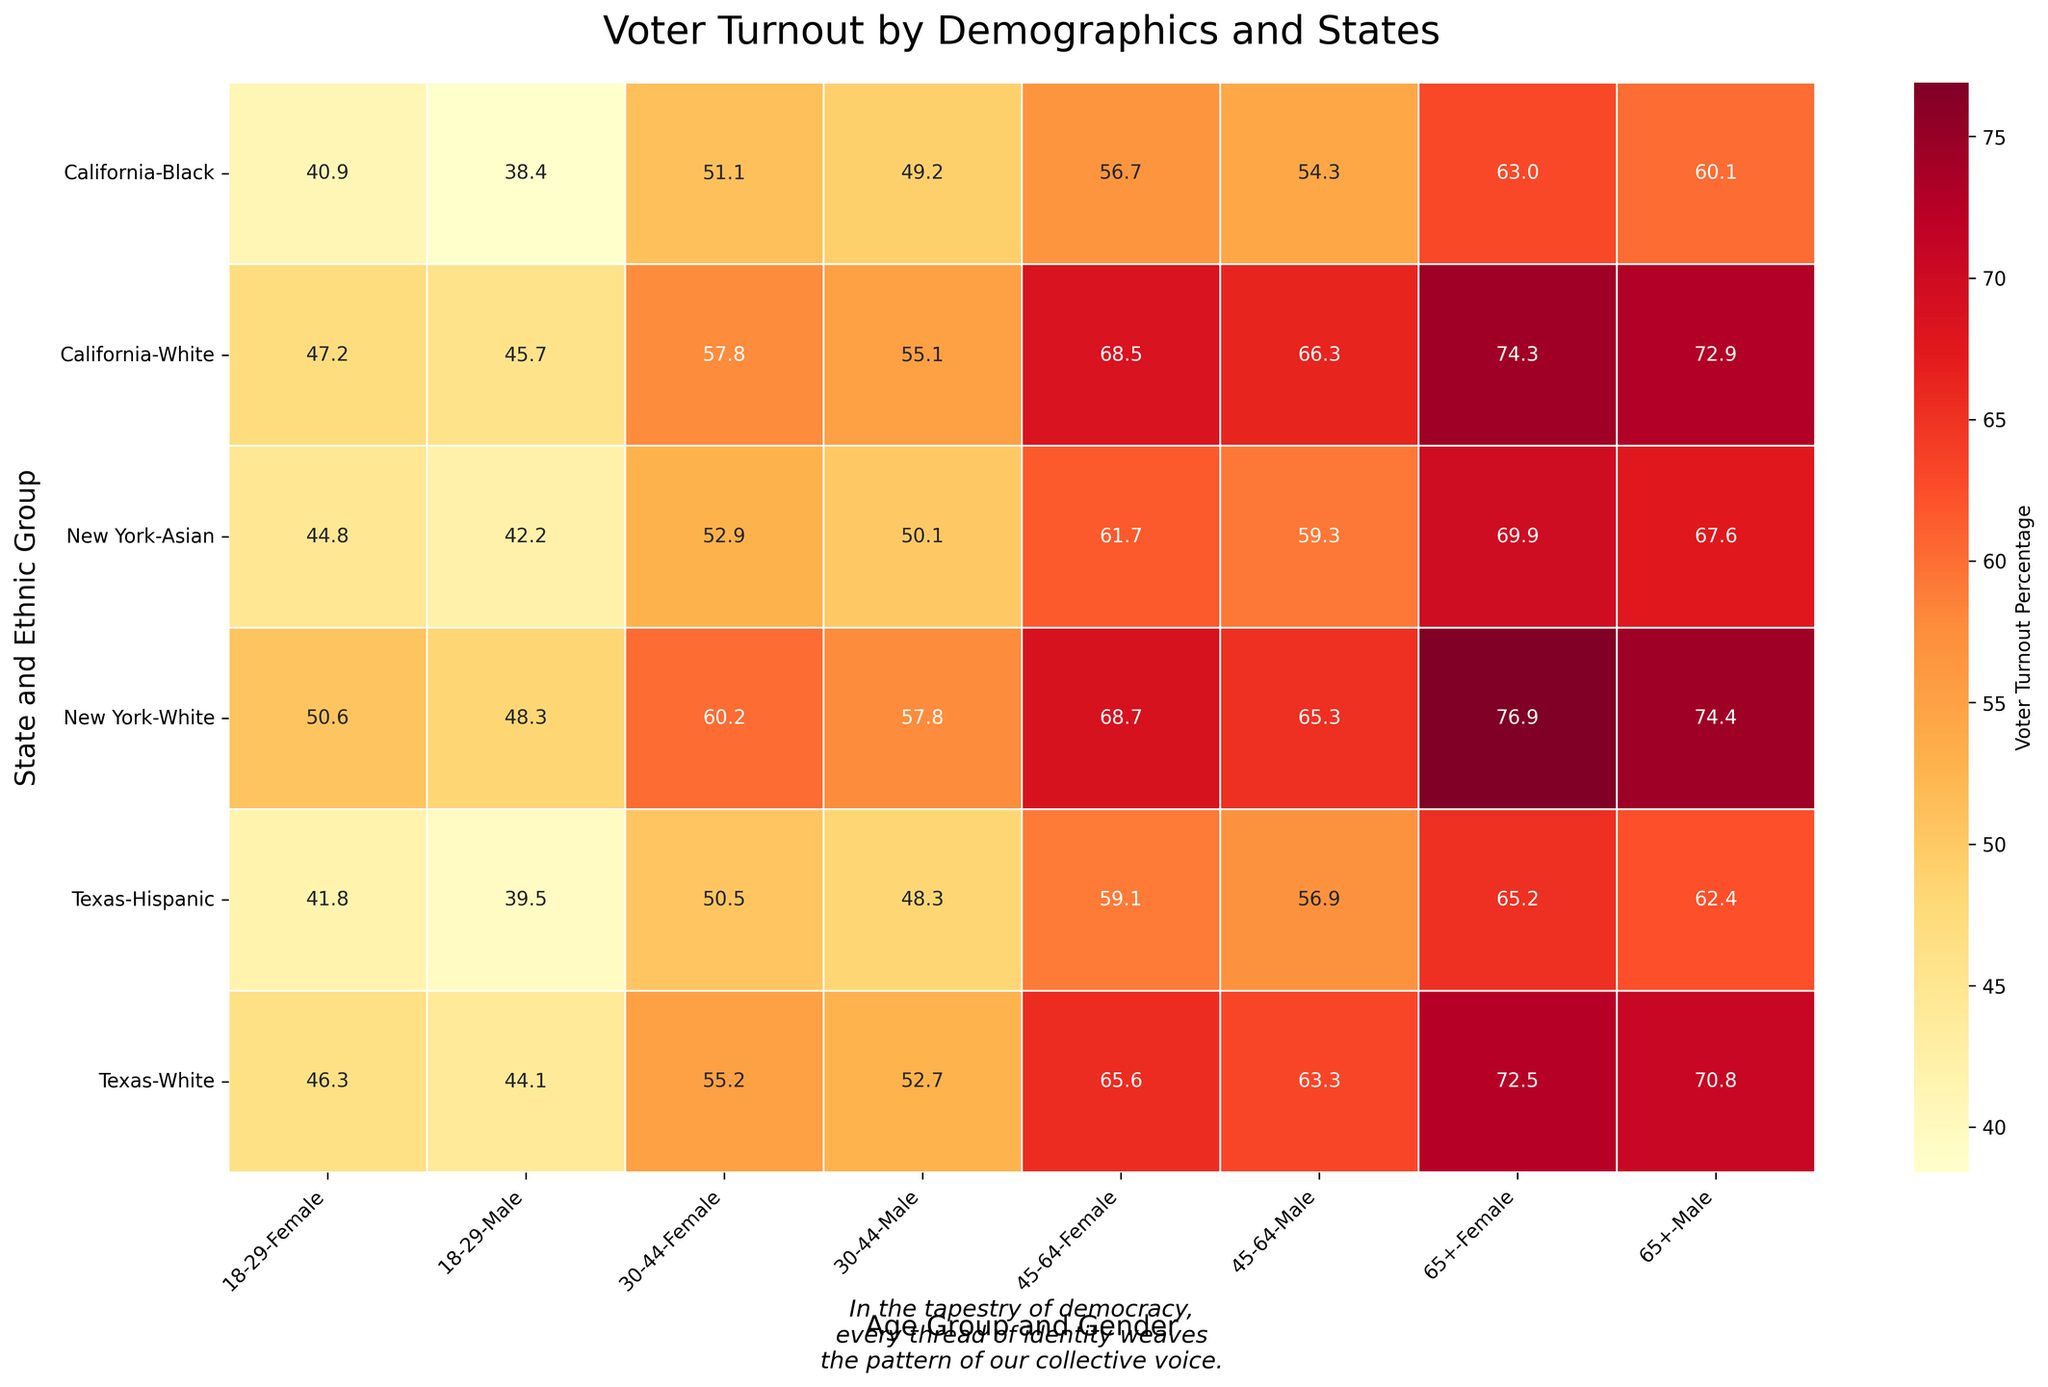What is the title of the heatmap? The title is found at the top-center of the plot.
Answer: Voter Turnout by Demographics and States Which age group and gender in Texas had the highest voter turnout percentage in 2016? Locate the Texas section, then look for the highest number under the 2016 Election Year. The highest value is under the 65+ age group and Female gender.
Answer: 72.5 Compare the voter turnout percentage of White males aged 18-29 in California for 2020 with that of Texas in 2016. Which state had the higher turnout and by how much? Find the White males aged 18-29 in the heatmap for both California in 2020 and Texas in 2016. The voter turnout percentages are 45.7 for California and 44.1 for Texas. The difference is 45.7 - 44.1.
Answer: California by 1.6 What is the average voter turnout percentage for Black females in California across all listed age groups in 2020? Identify the values for Black females in California for 2020, then sum them up and divide by the number of age groups. The turnout percentages are 40.9, 51.1, 56.7, and 63.0. The average is (40.9 + 51.1 + 56.7 + 63.0) / 4.
Answer: 52.9 Which ethnic group in New York showed the highest voter turnout among the 65+ age group in 2020? Locate New York's section and find the 65+ age group. Compare the percentages for each ethnic group, where White and Asian are options.
Answer: White females What is the voter turnout percentage difference between Hispanic males and females aged 45-64 in Texas for the 2020 election? Identify the column for Hispanics aged 45-64, compare values for males and females. Males have 56.9 and females have 59.1. The difference is 59.1 - 56.9.
Answer: 2.2 Is there any instance where the voter turnout percentage for Black males aged 18-29 is higher than that for White males aged 30-44 in the same state and election year? Compare the voter turnout for Black males aged 18-29 and White males aged 30-44 within the same state and election year in the heatmap. Across provided data, Black males aged 18-29 do not exceed White males aged 30-44.
Answer: No What are the voter turnout percentages for Asian females aged 30-44 and 45-64 in New York for 2020? Locate the values for Asian females in New York, specifically in the age groups 30-44 and 45-64 for 2020. The voter turnout percentages are 52.9 and 61.7.
Answer: 52.9 and 61.7 Which state exhibits the highest overall voter turnout percentage for White females in the 65+ age group regardless of the election year? Identify voter turnout percentages across all states for White females in the 65+ age group and compare the highest values. New York has the highest value with 76.9.
Answer: New York How does the voter turnout for Asian males aged 18-29 in New York compare to Hispanic males of the same age in Texas for 2020? Which group is higher, and by what amount? Locate voter turnout for Asian males aged 18-29 in New York and Hispanic males aged 18-29 in Texas for 2020. The values are 42.2 for New York and 39.5 for Texas. The difference is 42.2 - 39.5.
Answer: Asian males by 2.7 